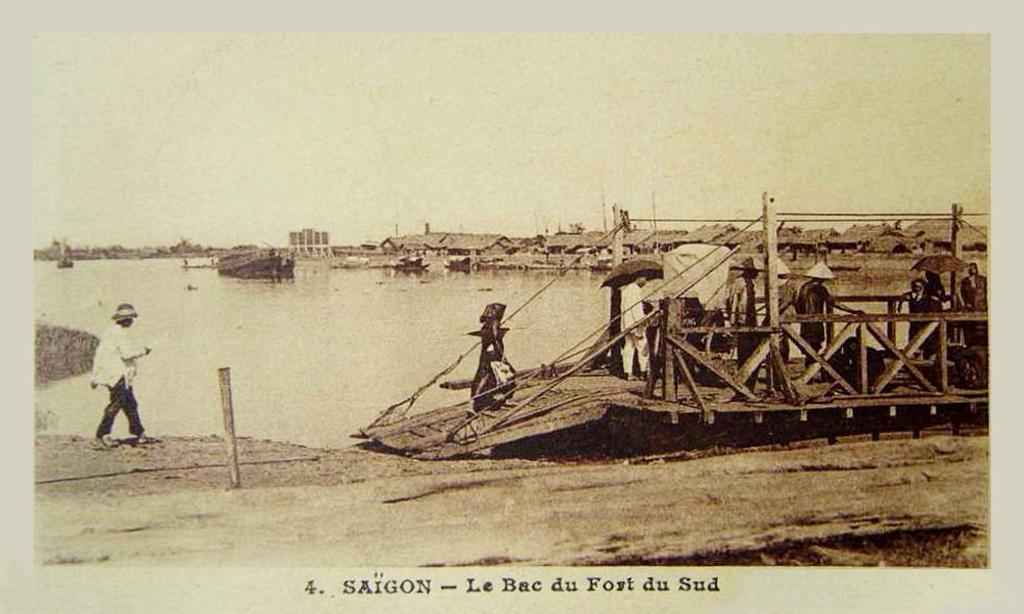Please provide a concise description of this image. This is a black and white picture. In the foreground of the picture there is soil. In the center of the picture there is a person walking and there is wooden object in water, on the object there are people and other objects. In the center of the picture there is a water body. In the background there are houses. At the bottom there is text. 